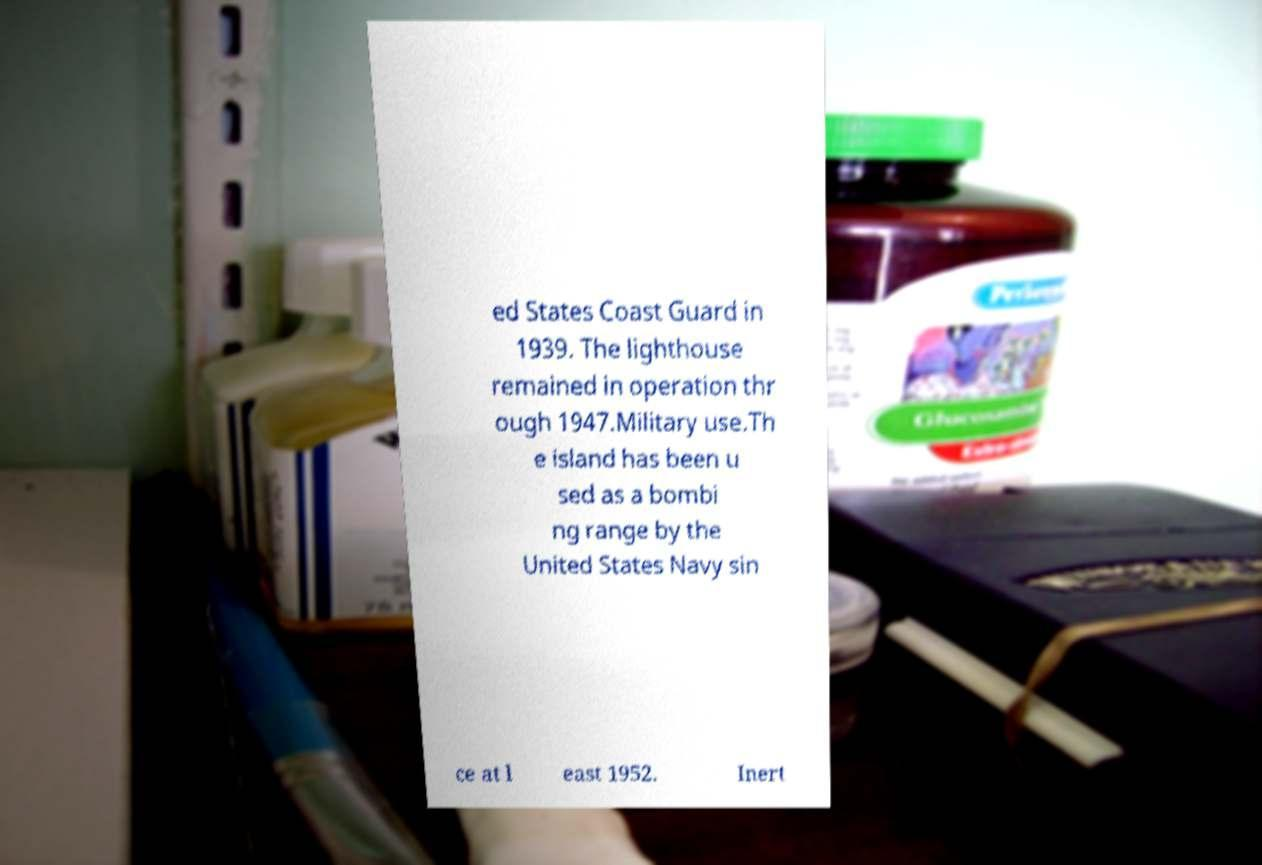Could you extract and type out the text from this image? ed States Coast Guard in 1939. The lighthouse remained in operation thr ough 1947.Military use.Th e island has been u sed as a bombi ng range by the United States Navy sin ce at l east 1952. Inert 